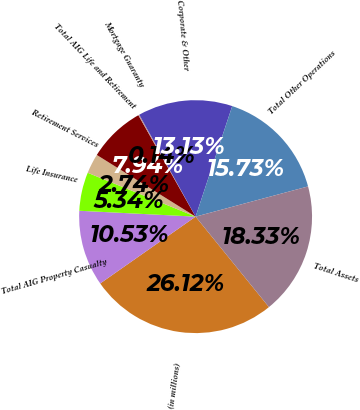Convert chart to OTSL. <chart><loc_0><loc_0><loc_500><loc_500><pie_chart><fcel>(in millions)<fcel>Total AIG Property Casualty<fcel>Life Insurance<fcel>Retirement Services<fcel>Total AIG Life and Retirement<fcel>Mortgage Guaranty<fcel>Corporate & Other<fcel>Total Other Operations<fcel>Total Assets<nl><fcel>26.12%<fcel>10.53%<fcel>5.34%<fcel>2.74%<fcel>7.94%<fcel>0.14%<fcel>13.13%<fcel>15.73%<fcel>18.33%<nl></chart> 